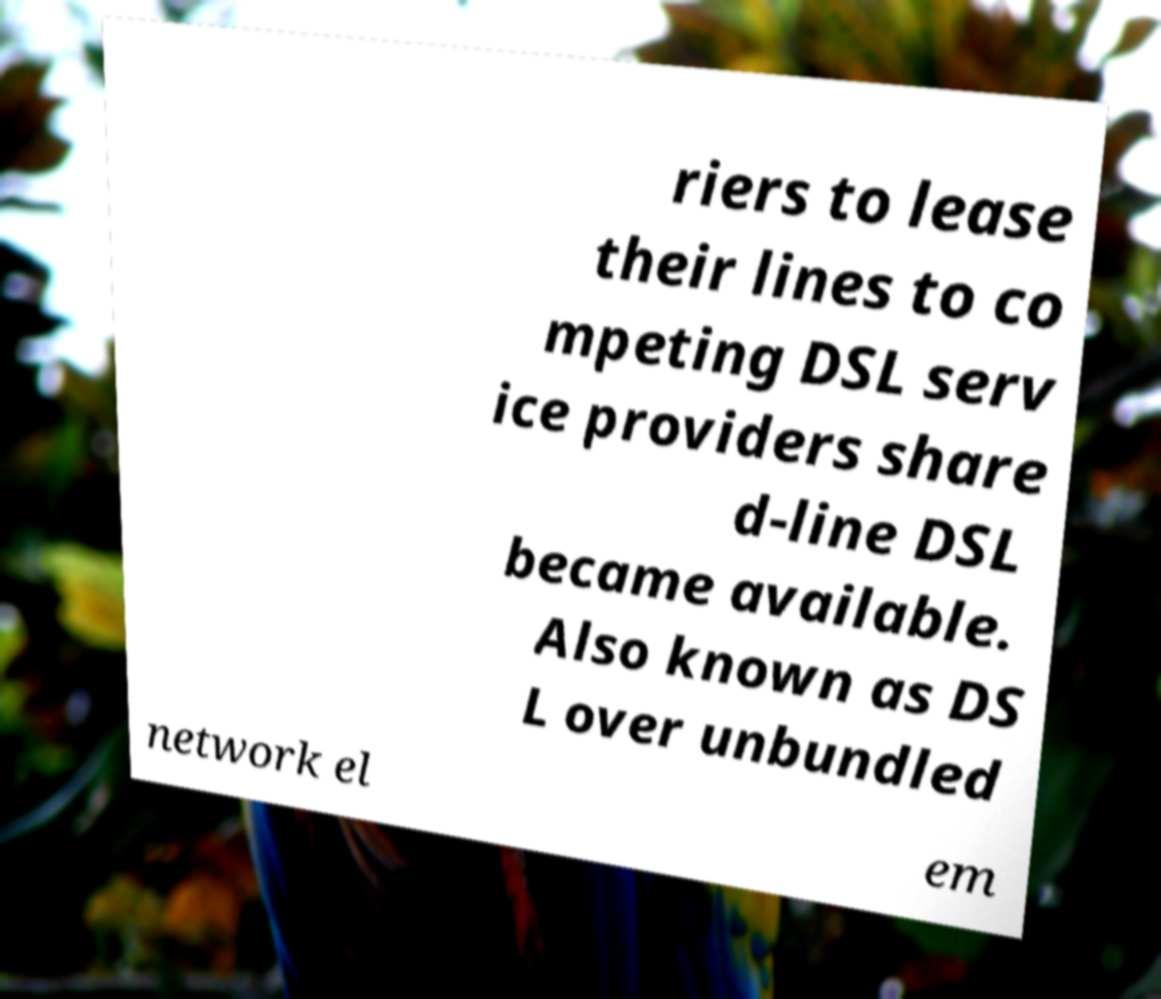Could you extract and type out the text from this image? riers to lease their lines to co mpeting DSL serv ice providers share d-line DSL became available. Also known as DS L over unbundled network el em 